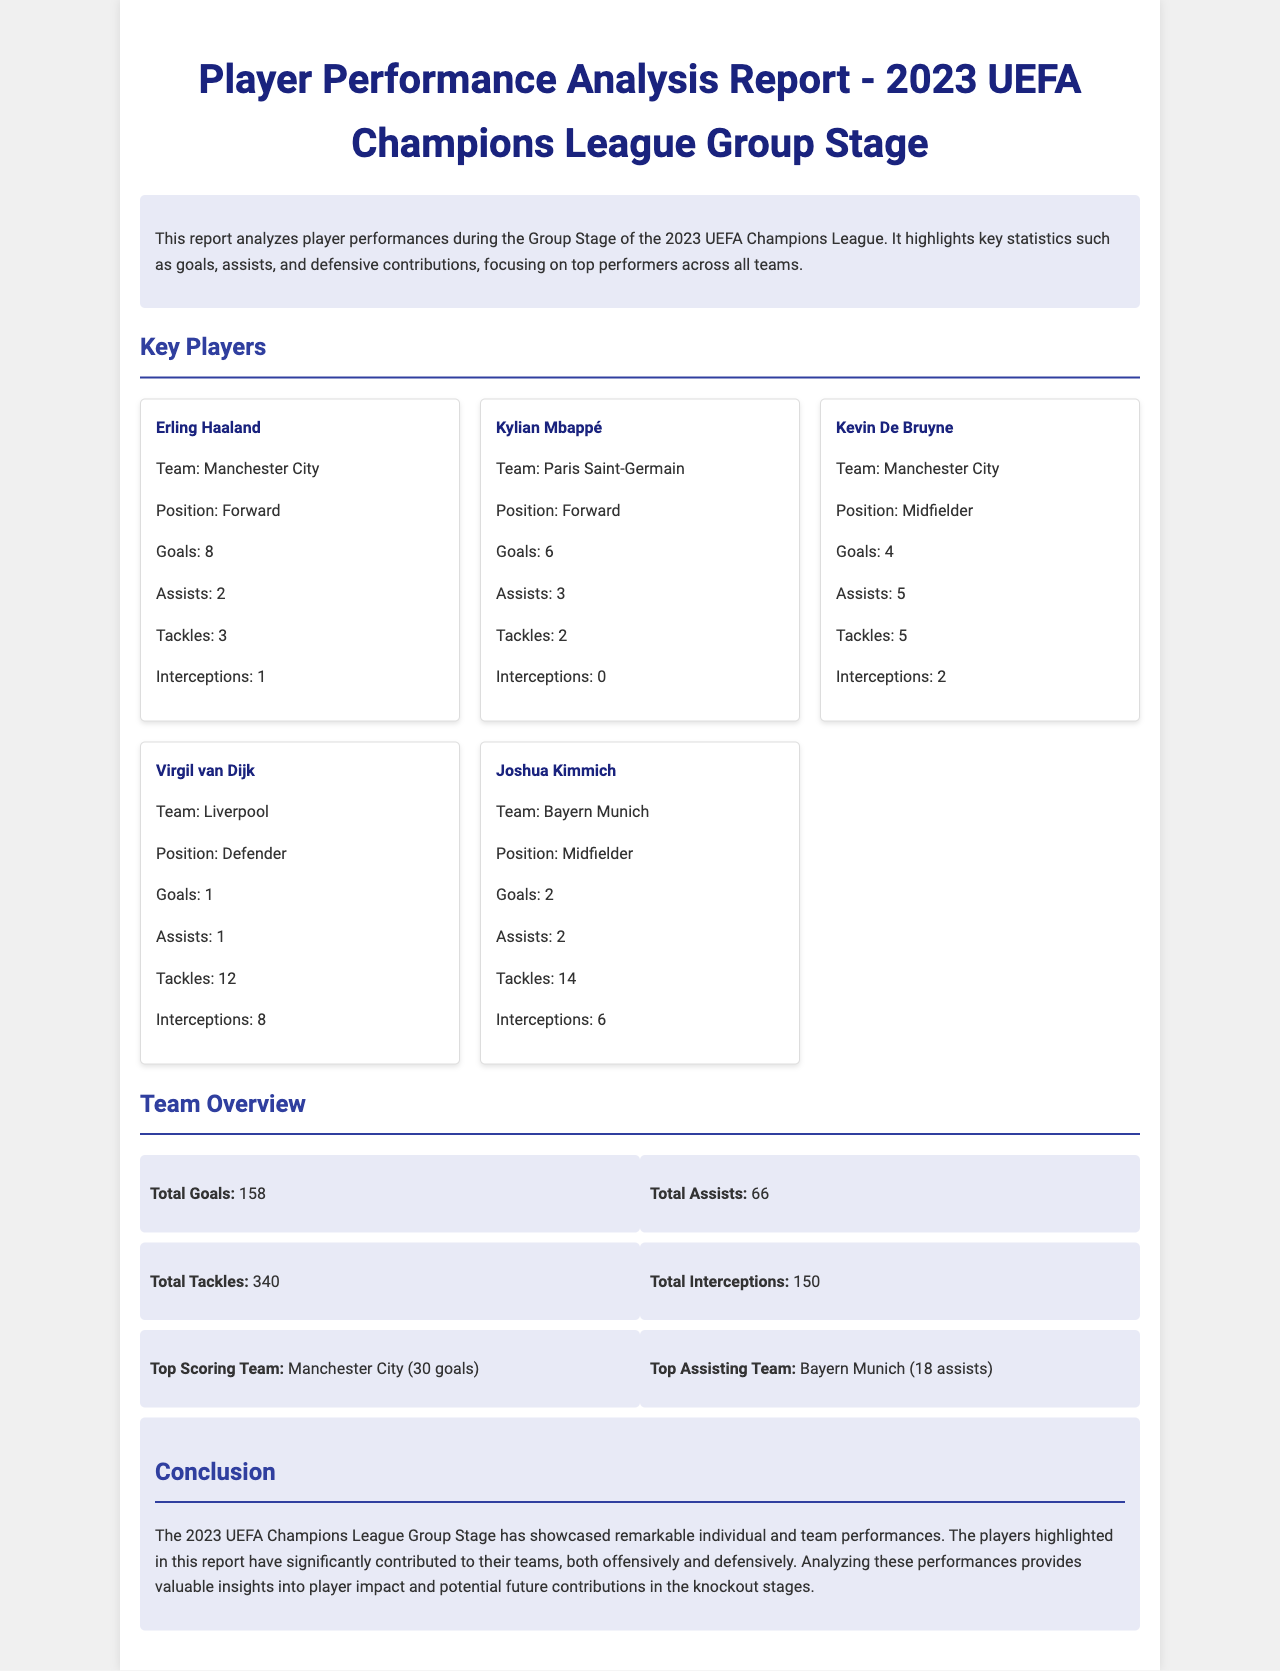What is the title of the report? The title of the report is stated prominently at the top of the document.
Answer: Player Performance Analysis Report - 2023 UEFA Champions League Group Stage How many goals did Erling Haaland score? The number of goals scored by Erling Haaland is listed within his player card.
Answer: 8 Who is the top assisting player? The top assisting player can be determined by comparing the assists listed for each player in the document.
Answer: Kevin De Bruyne What is the total number of tackles made by all players? The total number of tackles is summarized in the team overview section of the document.
Answer: 340 Which team had the highest number of goals? The team with the highest number of goals is mentioned in the team overview section.
Answer: Manchester City How many assists did Kylian Mbappé provide? Kylian Mbappé's assists are indicated in his player card.
Answer: 3 What defensive contribution did Virgil van Dijk make in terms of interceptions? The interceptions made by Virgil van Dijk are specified in his player card.
Answer: 8 Which player has the most tackles? The player with the most tackles can be found within the player cards by comparing their statistics.
Answer: Joshua Kimmich What is the total number of assists recorded in the group stage? The total number of assists is given in the team overview section of the document.
Answer: 66 